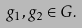Convert formula to latex. <formula><loc_0><loc_0><loc_500><loc_500>g _ { 1 } , g _ { 2 } \in G .</formula> 